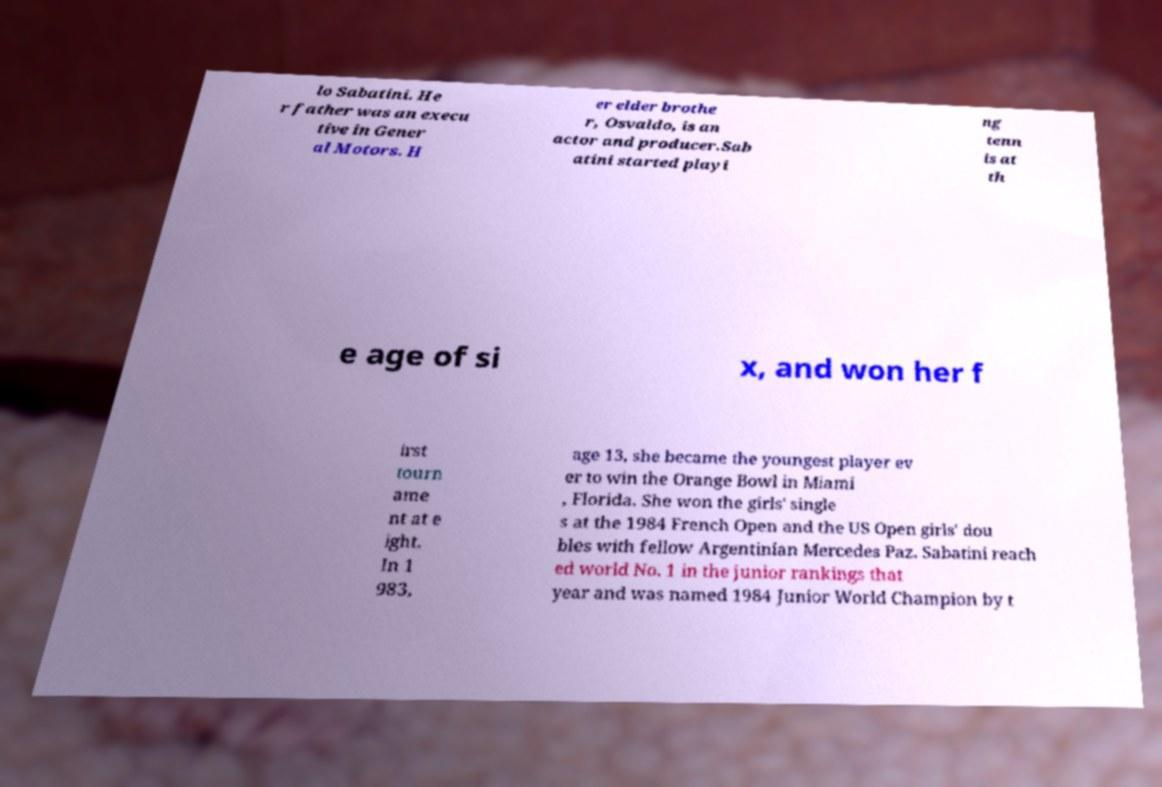Please identify and transcribe the text found in this image. lo Sabatini. He r father was an execu tive in Gener al Motors. H er elder brothe r, Osvaldo, is an actor and producer.Sab atini started playi ng tenn is at th e age of si x, and won her f irst tourn ame nt at e ight. In 1 983, age 13, she became the youngest player ev er to win the Orange Bowl in Miami , Florida. She won the girls' single s at the 1984 French Open and the US Open girls' dou bles with fellow Argentinian Mercedes Paz. Sabatini reach ed world No. 1 in the junior rankings that year and was named 1984 Junior World Champion by t 